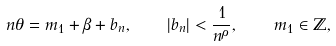Convert formula to latex. <formula><loc_0><loc_0><loc_500><loc_500>n \theta = m _ { 1 } + \beta + b _ { n } , \quad | b _ { n } | < \frac { 1 } { n ^ { \rho } } , \quad m _ { 1 } \in \mathbb { Z } ,</formula> 